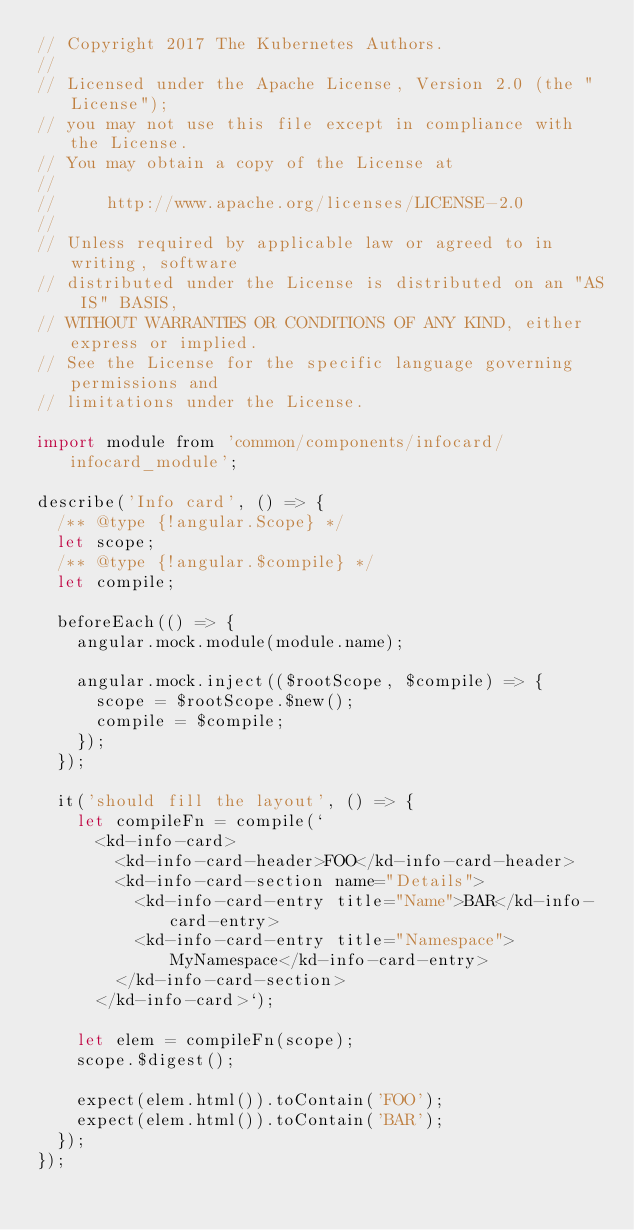Convert code to text. <code><loc_0><loc_0><loc_500><loc_500><_JavaScript_>// Copyright 2017 The Kubernetes Authors.
//
// Licensed under the Apache License, Version 2.0 (the "License");
// you may not use this file except in compliance with the License.
// You may obtain a copy of the License at
//
//     http://www.apache.org/licenses/LICENSE-2.0
//
// Unless required by applicable law or agreed to in writing, software
// distributed under the License is distributed on an "AS IS" BASIS,
// WITHOUT WARRANTIES OR CONDITIONS OF ANY KIND, either express or implied.
// See the License for the specific language governing permissions and
// limitations under the License.

import module from 'common/components/infocard/infocard_module';

describe('Info card', () => {
  /** @type {!angular.Scope} */
  let scope;
  /** @type {!angular.$compile} */
  let compile;

  beforeEach(() => {
    angular.mock.module(module.name);

    angular.mock.inject(($rootScope, $compile) => {
      scope = $rootScope.$new();
      compile = $compile;
    });
  });

  it('should fill the layout', () => {
    let compileFn = compile(`
      <kd-info-card>
        <kd-info-card-header>FOO</kd-info-card-header>
        <kd-info-card-section name="Details">
          <kd-info-card-entry title="Name">BAR</kd-info-card-entry>
          <kd-info-card-entry title="Namespace">MyNamespace</kd-info-card-entry>
        </kd-info-card-section>
      </kd-info-card>`);

    let elem = compileFn(scope);
    scope.$digest();

    expect(elem.html()).toContain('FOO');
    expect(elem.html()).toContain('BAR');
  });
});
</code> 